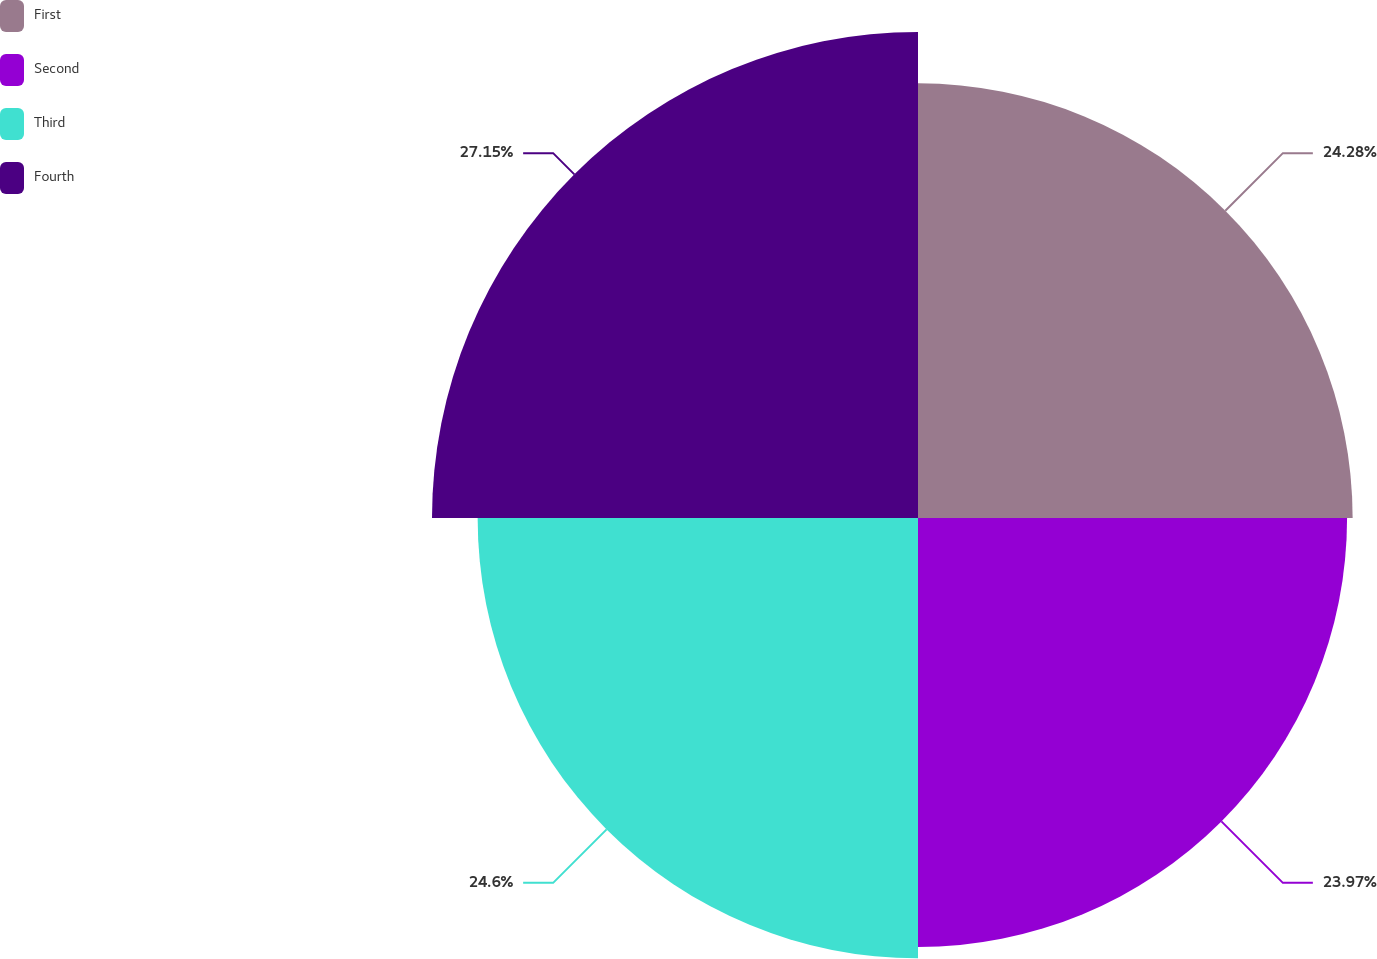Convert chart to OTSL. <chart><loc_0><loc_0><loc_500><loc_500><pie_chart><fcel>First<fcel>Second<fcel>Third<fcel>Fourth<nl><fcel>24.28%<fcel>23.97%<fcel>24.6%<fcel>27.15%<nl></chart> 